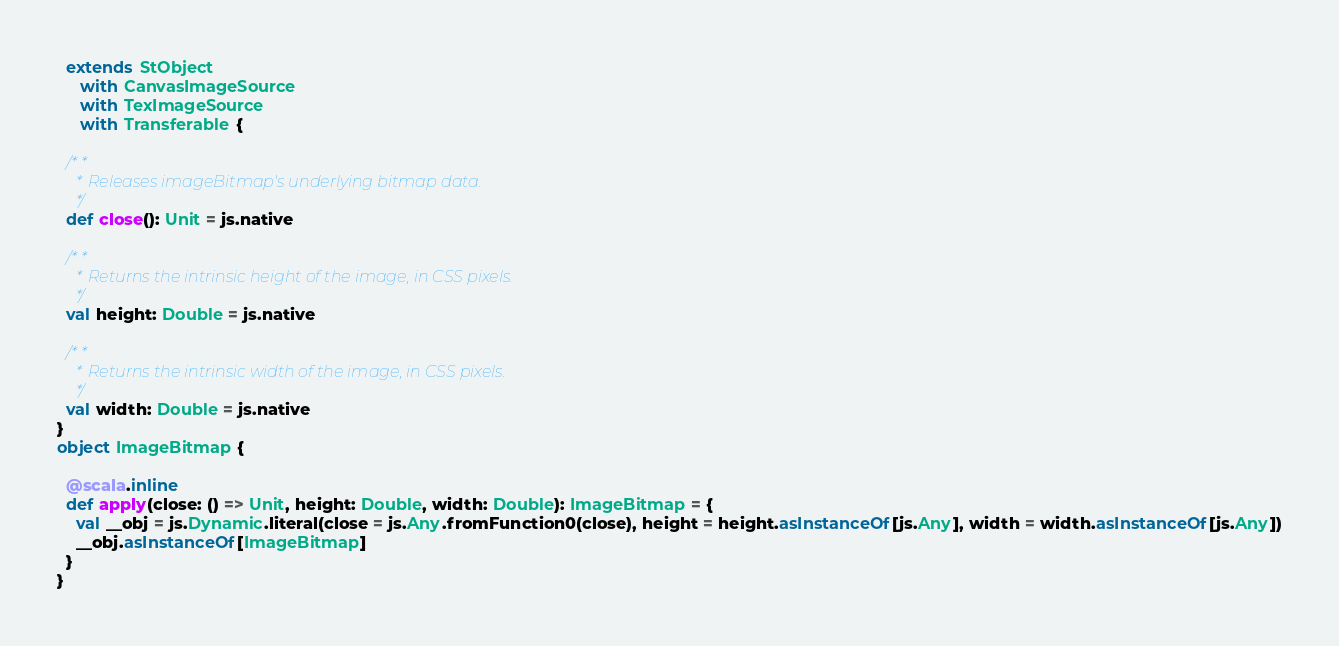<code> <loc_0><loc_0><loc_500><loc_500><_Scala_>  extends StObject
     with CanvasImageSource
     with TexImageSource
     with Transferable {
  
  /**
    * Releases imageBitmap's underlying bitmap data.
    */
  def close(): Unit = js.native
  
  /**
    * Returns the intrinsic height of the image, in CSS pixels.
    */
  val height: Double = js.native
  
  /**
    * Returns the intrinsic width of the image, in CSS pixels.
    */
  val width: Double = js.native
}
object ImageBitmap {
  
  @scala.inline
  def apply(close: () => Unit, height: Double, width: Double): ImageBitmap = {
    val __obj = js.Dynamic.literal(close = js.Any.fromFunction0(close), height = height.asInstanceOf[js.Any], width = width.asInstanceOf[js.Any])
    __obj.asInstanceOf[ImageBitmap]
  }
}
</code> 